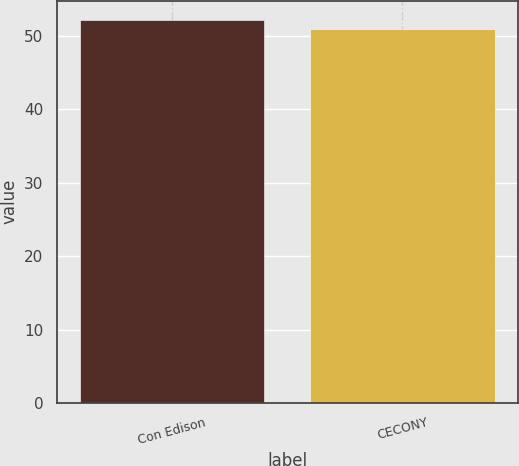Convert chart. <chart><loc_0><loc_0><loc_500><loc_500><bar_chart><fcel>Con Edison<fcel>CECONY<nl><fcel>52.2<fcel>50.9<nl></chart> 